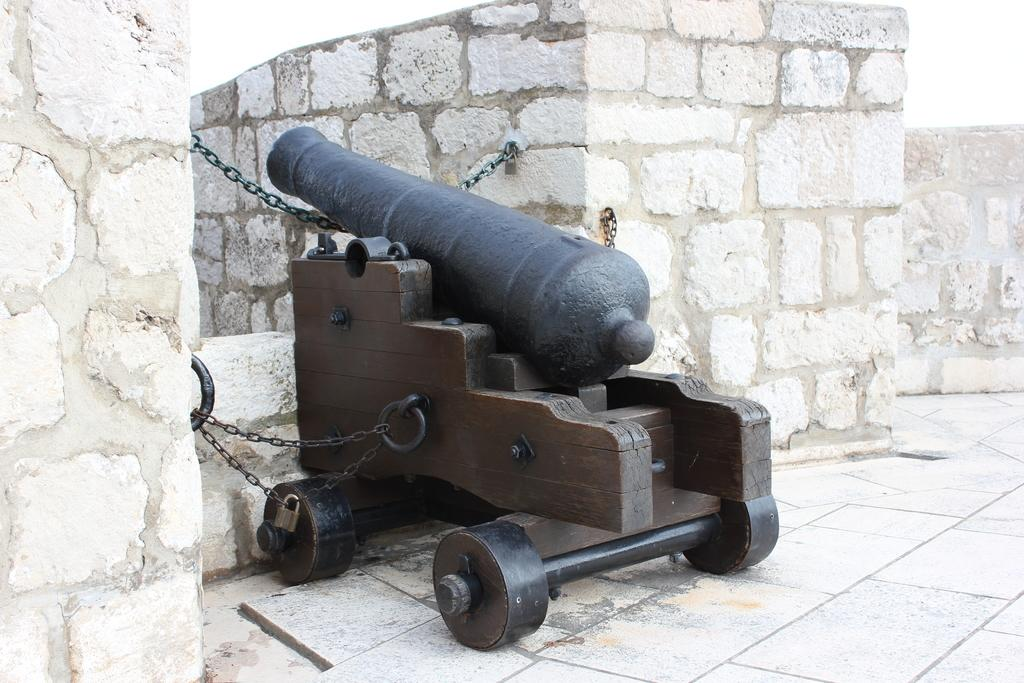What is the main object in the middle of the image? There is a cannon in the middle of the image. What can be seen on the right side of the image? There are walls on the right side of the image. What is visible at the top of the image? The sky is visible at the top of the image. How many sheep can be seen crossing the bridge in the image? There are no sheep or bridge present in the image. What type of shake is being offered at the cannon in the image? There is no shake being offered in the image; it features a cannon and walls. 